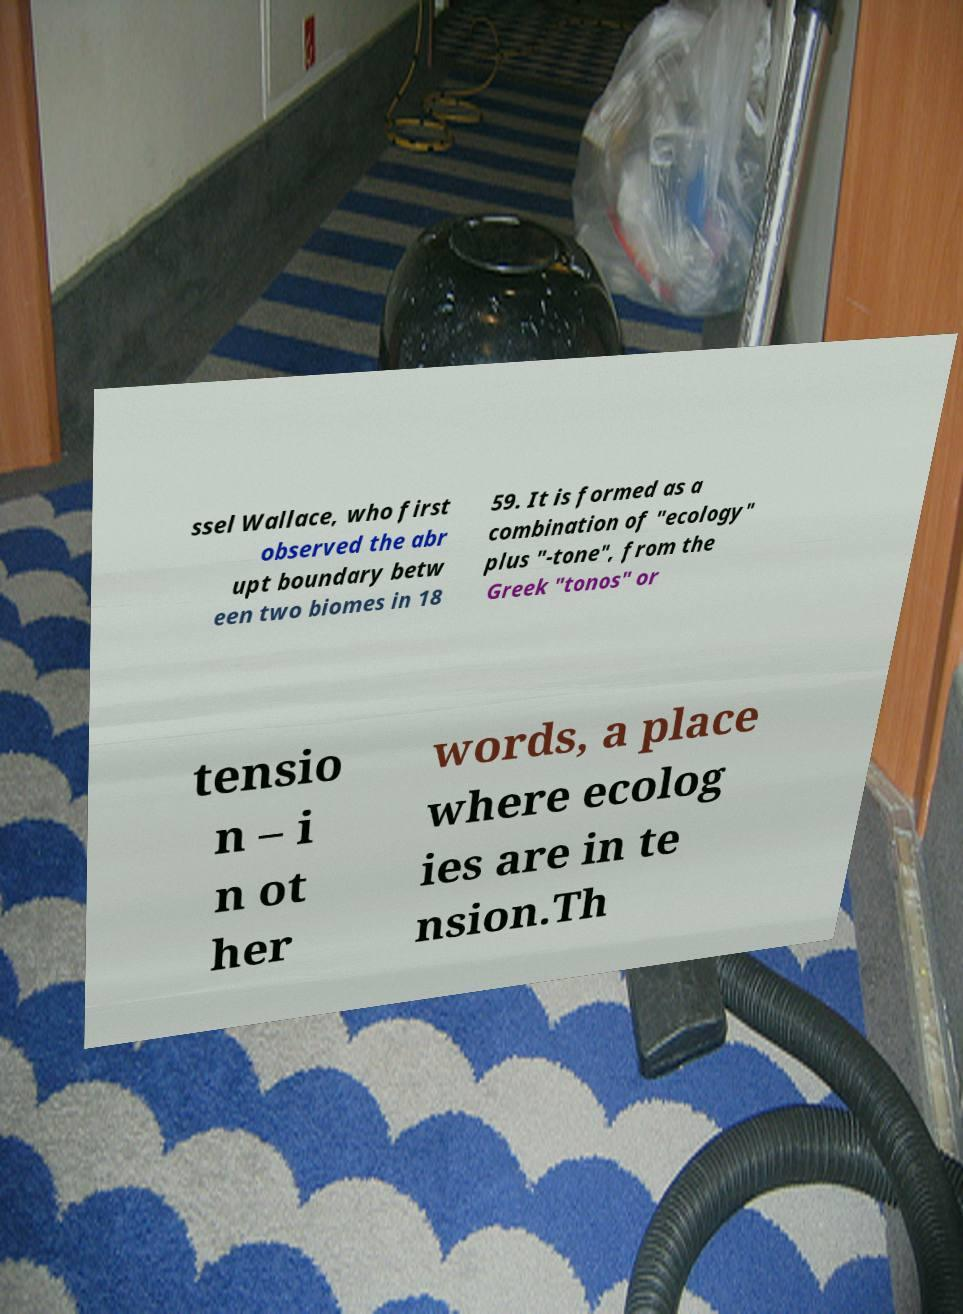Can you accurately transcribe the text from the provided image for me? ssel Wallace, who first observed the abr upt boundary betw een two biomes in 18 59. It is formed as a combination of "ecology" plus "-tone", from the Greek "tonos" or tensio n – i n ot her words, a place where ecolog ies are in te nsion.Th 